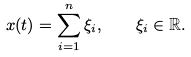<formula> <loc_0><loc_0><loc_500><loc_500>x ( t ) = \sum _ { i = 1 } ^ { n } \xi _ { i } , \quad \xi _ { i } \in \mathbb { R } .</formula> 